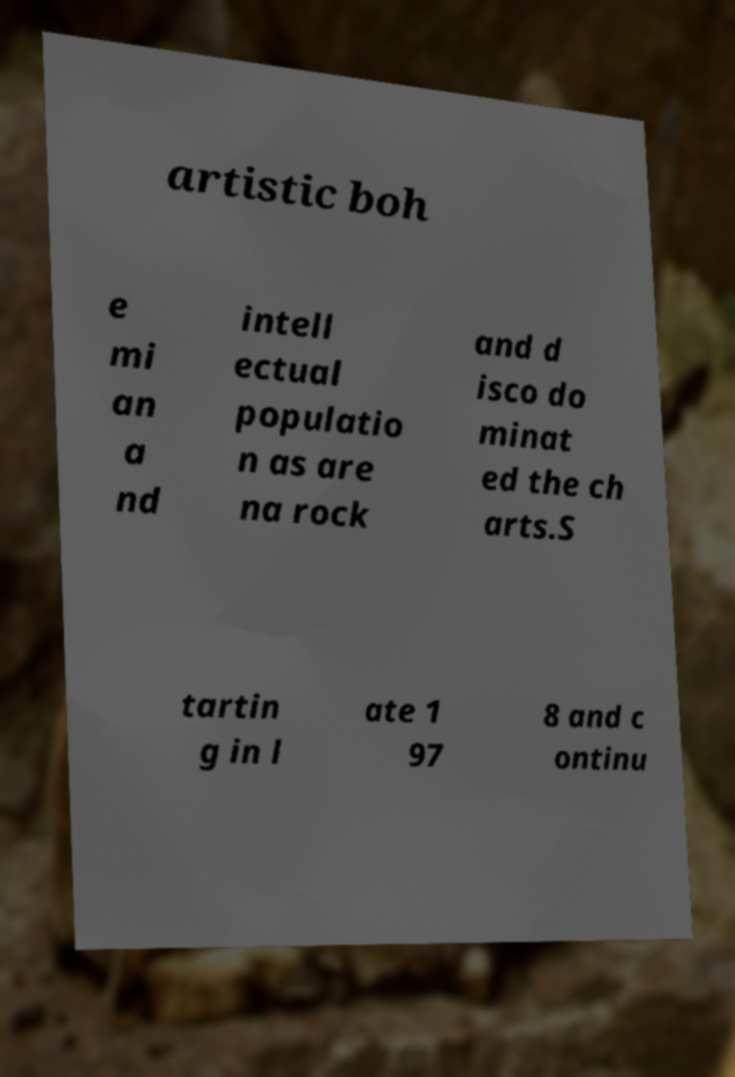I need the written content from this picture converted into text. Can you do that? artistic boh e mi an a nd intell ectual populatio n as are na rock and d isco do minat ed the ch arts.S tartin g in l ate 1 97 8 and c ontinu 